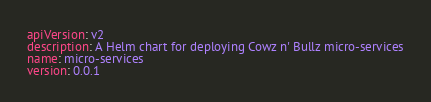Convert code to text. <code><loc_0><loc_0><loc_500><loc_500><_YAML_>apiVersion: v2
description: A Helm chart for deploying Cowz n' Bullz micro-services
name: micro-services
version: 0.0.1
</code> 